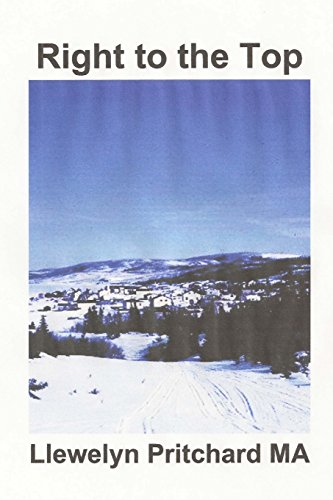Can you give an overall summary of what this book might cover? The book appears to be a mystery novel, likely filled with intrigue and suspense. It probably delves into corruption and the challenges of battling against corrupt groups, as suggested by its subtitle. 